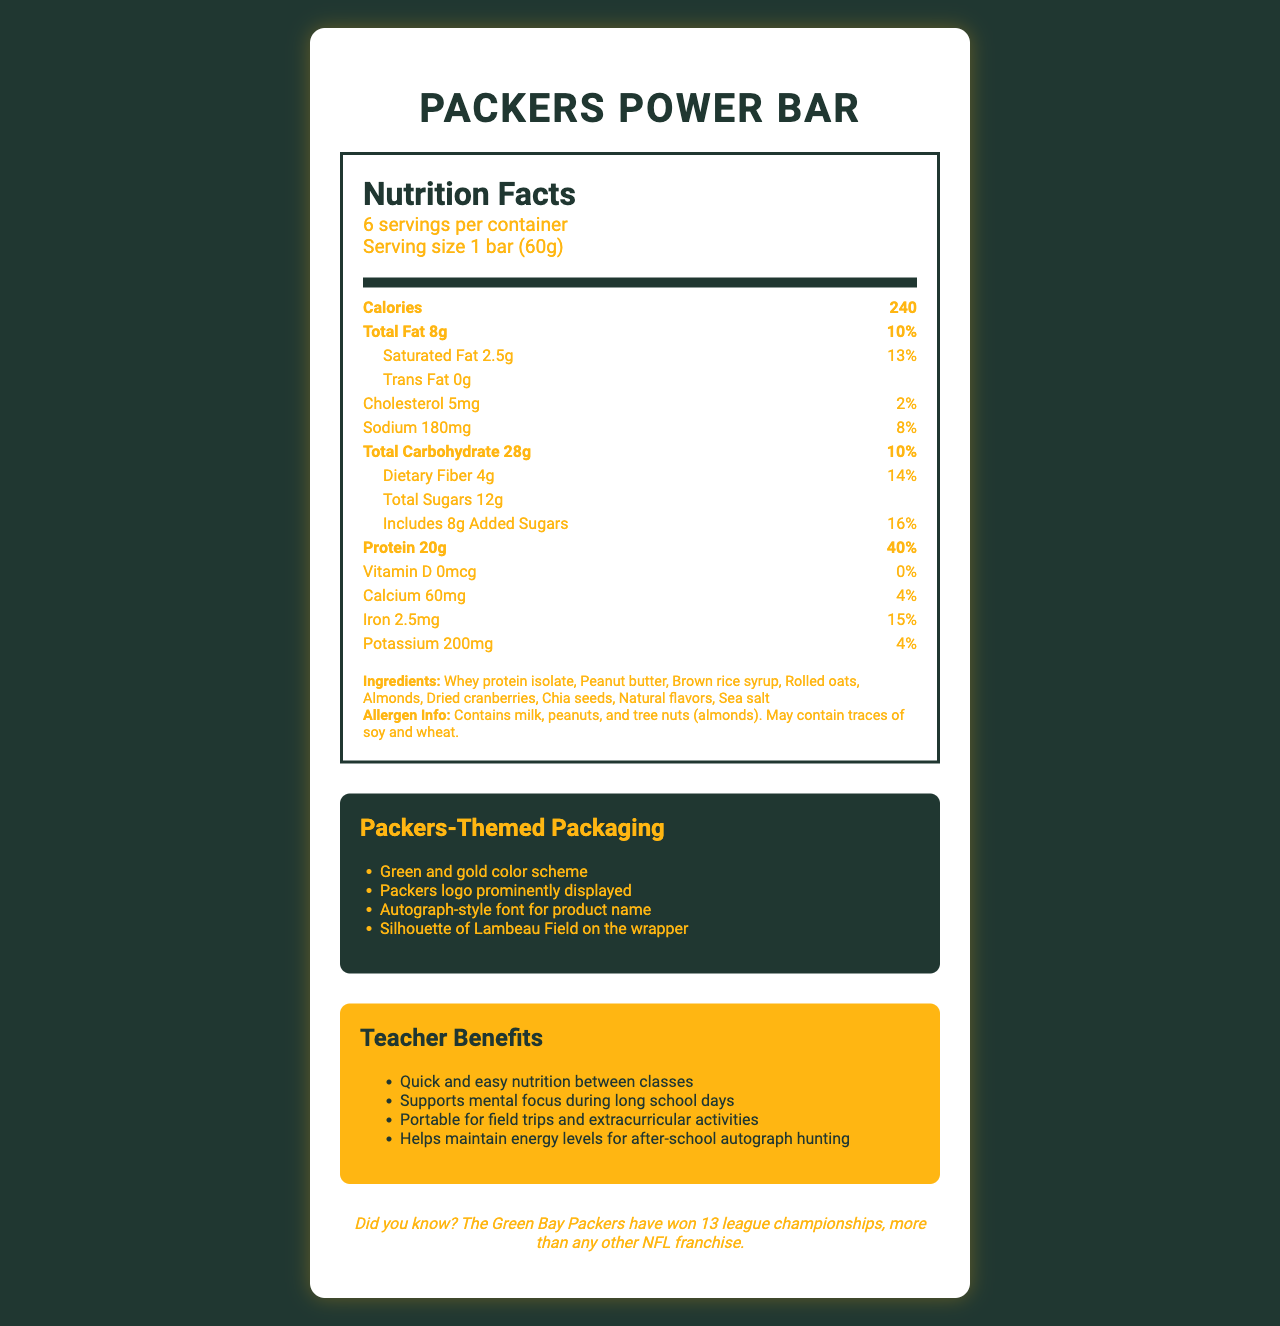what is the serving size of the Packers Power Bar? The serving size is specified as "1 bar (60g)" in the serving information.
Answer: 1 bar (60g) how many servings are there per container? The document states that there are 6 servings per container.
Answer: 6 servings how many grams of total fat are in one serving? The total fat content per serving is listed as 8g.
Answer: 8g what percentage of the daily value does the protein content represent? The protein content represents 40% of the daily value for protein.
Answer: 40% name three allergens contained in the Packers Power Bar. The allergen information lists milk, peanuts, and tree nuts (almonds).
Answer: Milk, peanuts, almonds what is the sodium content per serving? The sodium content per serving is stated as 180mg.
Answer: 180mg how much dietary fiber is in each serving of the Packers Power Bar? Each serving contains 4g of dietary fiber.
Answer: 4g what is the iron daily value percentage in one serving? The document mentions that the iron content in one serving provides 15% of the daily value.
Answer: 15% which ingredient is listed first? The first ingredient listed is whey protein isolate.
Answer: Whey protein isolate what flavors does the Packers Power Bar include? The ingredients list includes natural flavors.
Answer: Natural flavors how many grams of added sugars are in one serving? The document specifies that one serving includes 8g of added sugars.
Answer: 8g how much calcium is in one serving of the bar? The calcium content per serving is listed as 60mg.
Answer: 60mg what is the packaging color scheme for the Packers Power Bar? The packaging features a green and gold color scheme.
Answer: Green and gold what is the silhouette shown on the bar's wrapper? The wrapper includes a silhouette of Lambeau Field.
Answer: Lambeau Field what is one benefit mentioned for teachers? The document lists "Quick and easy nutrition between classes" as one benefit for teachers.
Answer: Quick and easy nutrition between classes which of the following is NOT one of the ingredients? A. Peanuts B. Rolled oats C. Soybeans D. Sea salt Soybeans are not listed among the ingredients.
Answer: C. Soybeans what is the calories content per serving? A. 200 B. 240 C. 180 D. 260 The document states that each serving contains 240 calories.
Answer: B. 240 does the Packers Power Bar contain any trans fat? The trans fat content is listed as 0g, meaning there is no trans fat.
Answer: No is vitamin D present in the Packers Power Bar? The vitamin D content is 0mcg, indicating it is not present.
Answer: No summarize the main purpose of the document. The document presents a comprehensive overview of the Packers Power Bar, detailing nutritional content, allergens, packaging features, benefits for teachers, and Packers trivia.
Answer: The document provides detailed nutritional information for the Packers Power Bar, highlighting its high protein content, ingredients, and benefits for teachers. It also emphasizes the Packers-themed packaging and includes a piece of trivia about the Green Bay Packers. how long has the teacher been collecting autographs? The document does not provide any information about how long the teacher has been collecting autographs.
Answer: Not enough information 